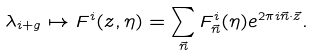<formula> <loc_0><loc_0><loc_500><loc_500>\lambda _ { i + g } \mapsto F ^ { i } ( z , \eta ) = \sum _ { \vec { n } } F _ { \vec { n } } ^ { i } ( \eta ) e ^ { 2 \pi i \vec { n } \cdot \vec { z } } .</formula> 